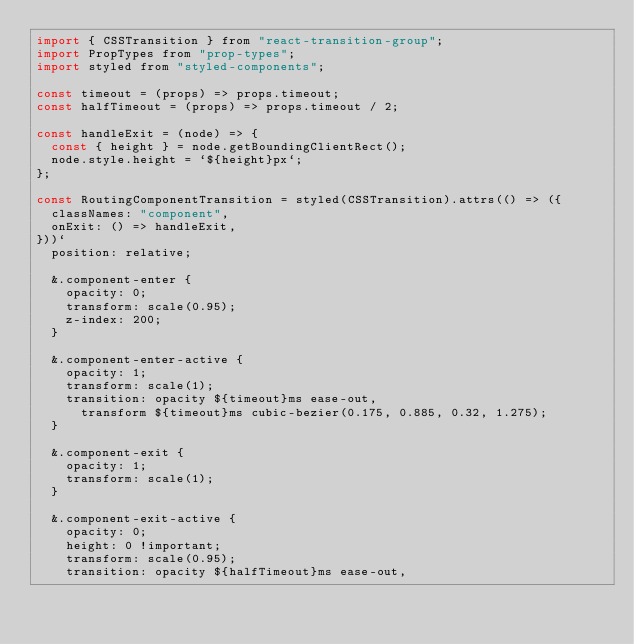Convert code to text. <code><loc_0><loc_0><loc_500><loc_500><_JavaScript_>import { CSSTransition } from "react-transition-group";
import PropTypes from "prop-types";
import styled from "styled-components";

const timeout = (props) => props.timeout;
const halfTimeout = (props) => props.timeout / 2;

const handleExit = (node) => {
  const { height } = node.getBoundingClientRect();
  node.style.height = `${height}px`;
};

const RoutingComponentTransition = styled(CSSTransition).attrs(() => ({
  classNames: "component",
  onExit: () => handleExit,
}))`
  position: relative;

  &.component-enter {
    opacity: 0;
    transform: scale(0.95);
    z-index: 200;
  }

  &.component-enter-active {
    opacity: 1;
    transform: scale(1);
    transition: opacity ${timeout}ms ease-out,
      transform ${timeout}ms cubic-bezier(0.175, 0.885, 0.32, 1.275);
  }

  &.component-exit {
    opacity: 1;
    transform: scale(1);
  }

  &.component-exit-active {
    opacity: 0;
    height: 0 !important;
    transform: scale(0.95);
    transition: opacity ${halfTimeout}ms ease-out,</code> 